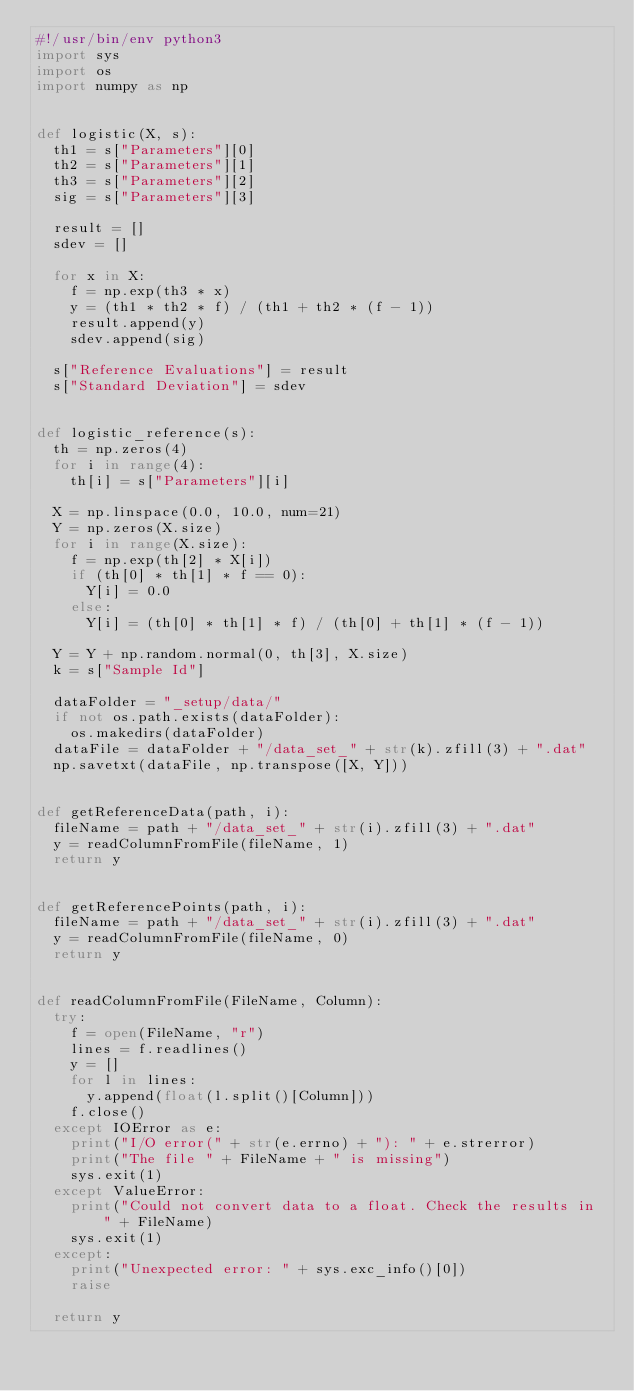<code> <loc_0><loc_0><loc_500><loc_500><_Python_>#!/usr/bin/env python3
import sys
import os
import numpy as np


def logistic(X, s):
  th1 = s["Parameters"][0]
  th2 = s["Parameters"][1]
  th3 = s["Parameters"][2]
  sig = s["Parameters"][3]

  result = []
  sdev = []

  for x in X:
    f = np.exp(th3 * x)
    y = (th1 * th2 * f) / (th1 + th2 * (f - 1))
    result.append(y)
    sdev.append(sig)

  s["Reference Evaluations"] = result
  s["Standard Deviation"] = sdev


def logistic_reference(s):
  th = np.zeros(4)
  for i in range(4):
    th[i] = s["Parameters"][i]

  X = np.linspace(0.0, 10.0, num=21)
  Y = np.zeros(X.size)
  for i in range(X.size):
    f = np.exp(th[2] * X[i])
    if (th[0] * th[1] * f == 0):
      Y[i] = 0.0
    else:
      Y[i] = (th[0] * th[1] * f) / (th[0] + th[1] * (f - 1))

  Y = Y + np.random.normal(0, th[3], X.size)
  k = s["Sample Id"]

  dataFolder = "_setup/data/"
  if not os.path.exists(dataFolder):
    os.makedirs(dataFolder)
  dataFile = dataFolder + "/data_set_" + str(k).zfill(3) + ".dat"
  np.savetxt(dataFile, np.transpose([X, Y]))


def getReferenceData(path, i):
  fileName = path + "/data_set_" + str(i).zfill(3) + ".dat"
  y = readColumnFromFile(fileName, 1)
  return y


def getReferencePoints(path, i):
  fileName = path + "/data_set_" + str(i).zfill(3) + ".dat"
  y = readColumnFromFile(fileName, 0)
  return y


def readColumnFromFile(FileName, Column):
  try:
    f = open(FileName, "r")
    lines = f.readlines()
    y = []
    for l in lines:
      y.append(float(l.split()[Column]))
    f.close()
  except IOError as e:
    print("I/O error(" + str(e.errno) + "): " + e.strerror)
    print("The file " + FileName + " is missing")
    sys.exit(1)
  except ValueError:
    print("Could not convert data to a float. Check the results in " + FileName)
    sys.exit(1)
  except:
    print("Unexpected error: " + sys.exc_info()[0])
    raise

  return y
</code> 